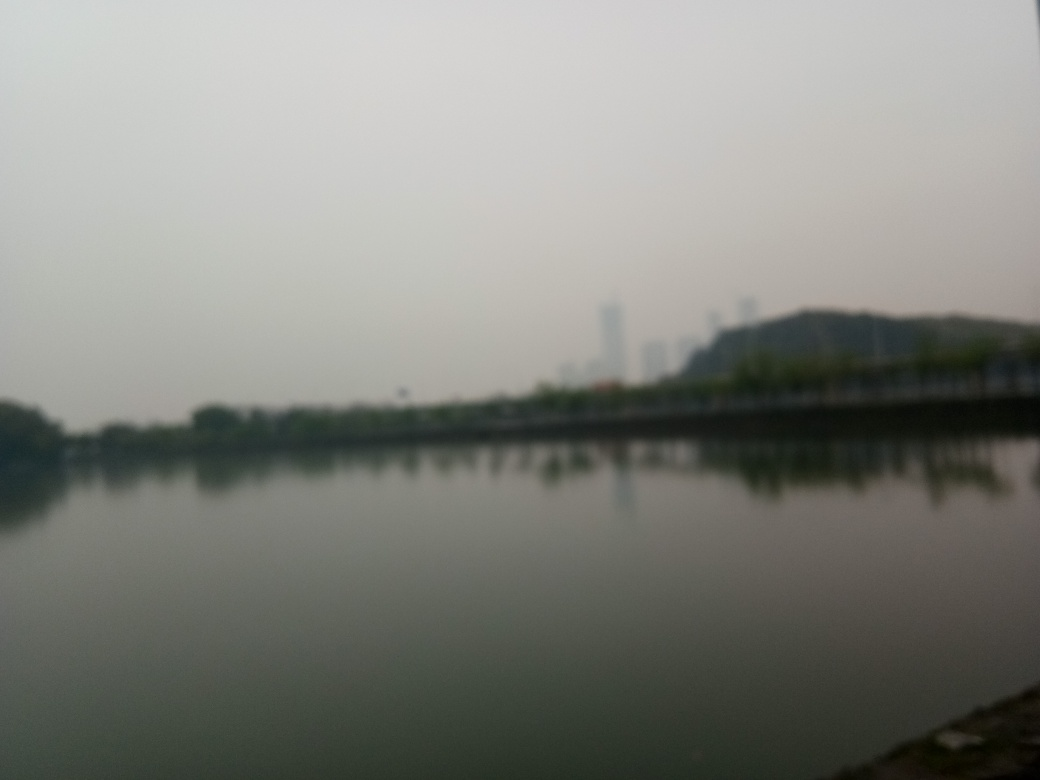What time of day does this photo look like it was taken? Judging from the diffuse light and lack of strong shadows, it's plausible that the photo was taken either in the morning or late afternoon. However, the exact time is difficult to determine due to the image's overall haze and the absence of distinct lighting cues that typically indicate the position of the sun. 